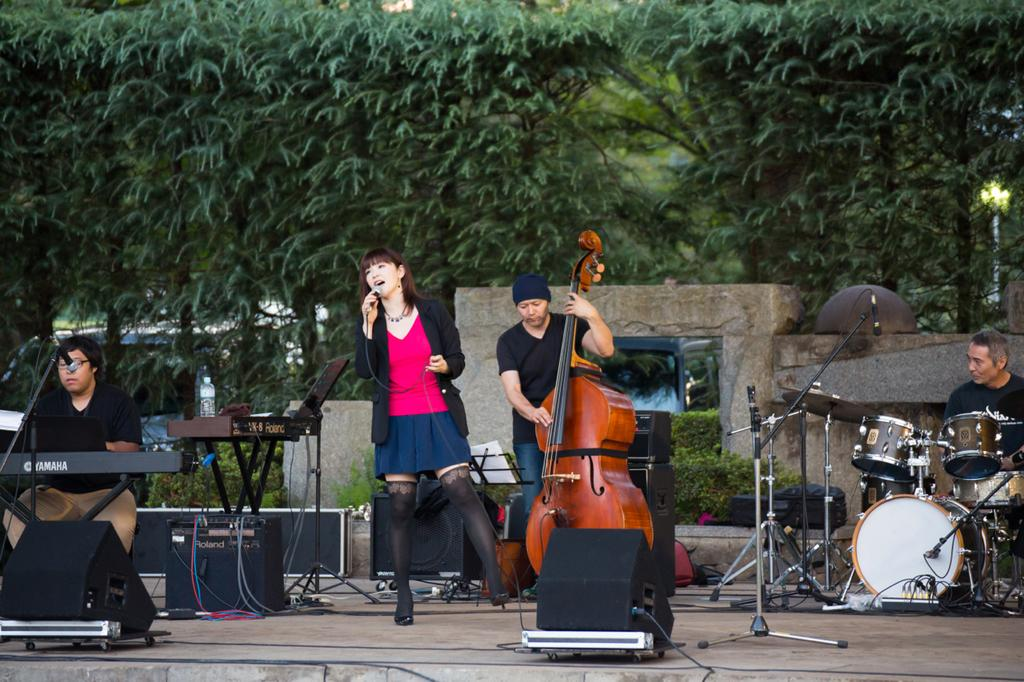How many people are on stage in the image? There are four people on stage in the image. What are three of the people doing on stage? Three of the people are playing musical instruments. What is the woman on stage doing? The woman is singing on a microphone. What is used to amplify the sound in the image? There are speakers present in the image. What are the stands on stage used for? The stands on stage are likely used to hold the musical instruments. What can be seen in the background of the image? Trees are visible in the background of the image. What type of ice can be seen melting on the stage in the image? There is no ice present in the image; it features people on stage performing. 